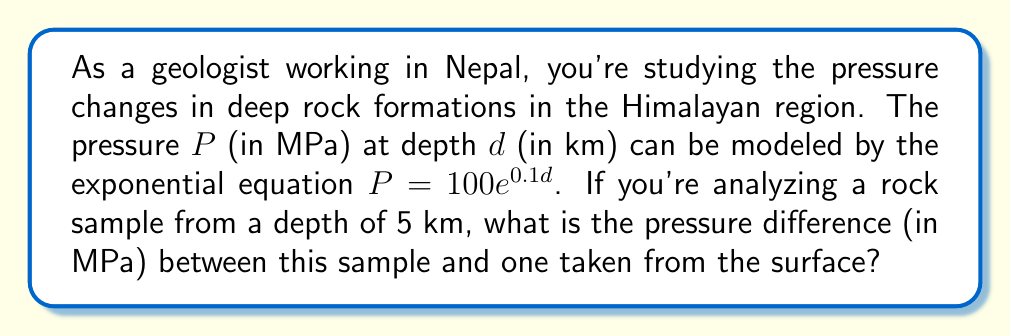Provide a solution to this math problem. To solve this problem, we need to:
1. Calculate the pressure at 5 km depth
2. Calculate the pressure at the surface (0 km depth)
3. Find the difference between these two pressures

Step 1: Pressure at 5 km depth
$$P_{5km} = 100e^{0.1(5)}$$
$$P_{5km} = 100e^{0.5}$$
$$P_{5km} = 100 \cdot 1.6487$$
$$P_{5km} = 164.87 \text{ MPa}$$

Step 2: Pressure at the surface (0 km depth)
$$P_{0km} = 100e^{0.1(0)}$$
$$P_{0km} = 100e^0$$
$$P_{0km} = 100 \cdot 1$$
$$P_{0km} = 100 \text{ MPa}$$

Step 3: Pressure difference
$$\Delta P = P_{5km} - P_{0km}$$
$$\Delta P = 164.87 - 100$$
$$\Delta P = 64.87 \text{ MPa}$$
Answer: The pressure difference between the rock sample at 5 km depth and the surface is 64.87 MPa. 